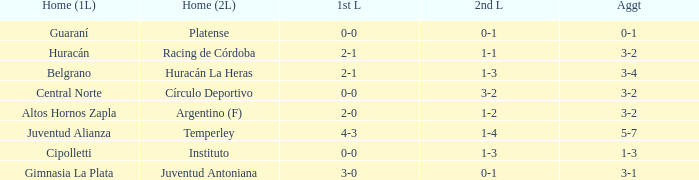In which team's home game did they achieve an aggregate score of 3-4 in the first leg? Belgrano. 